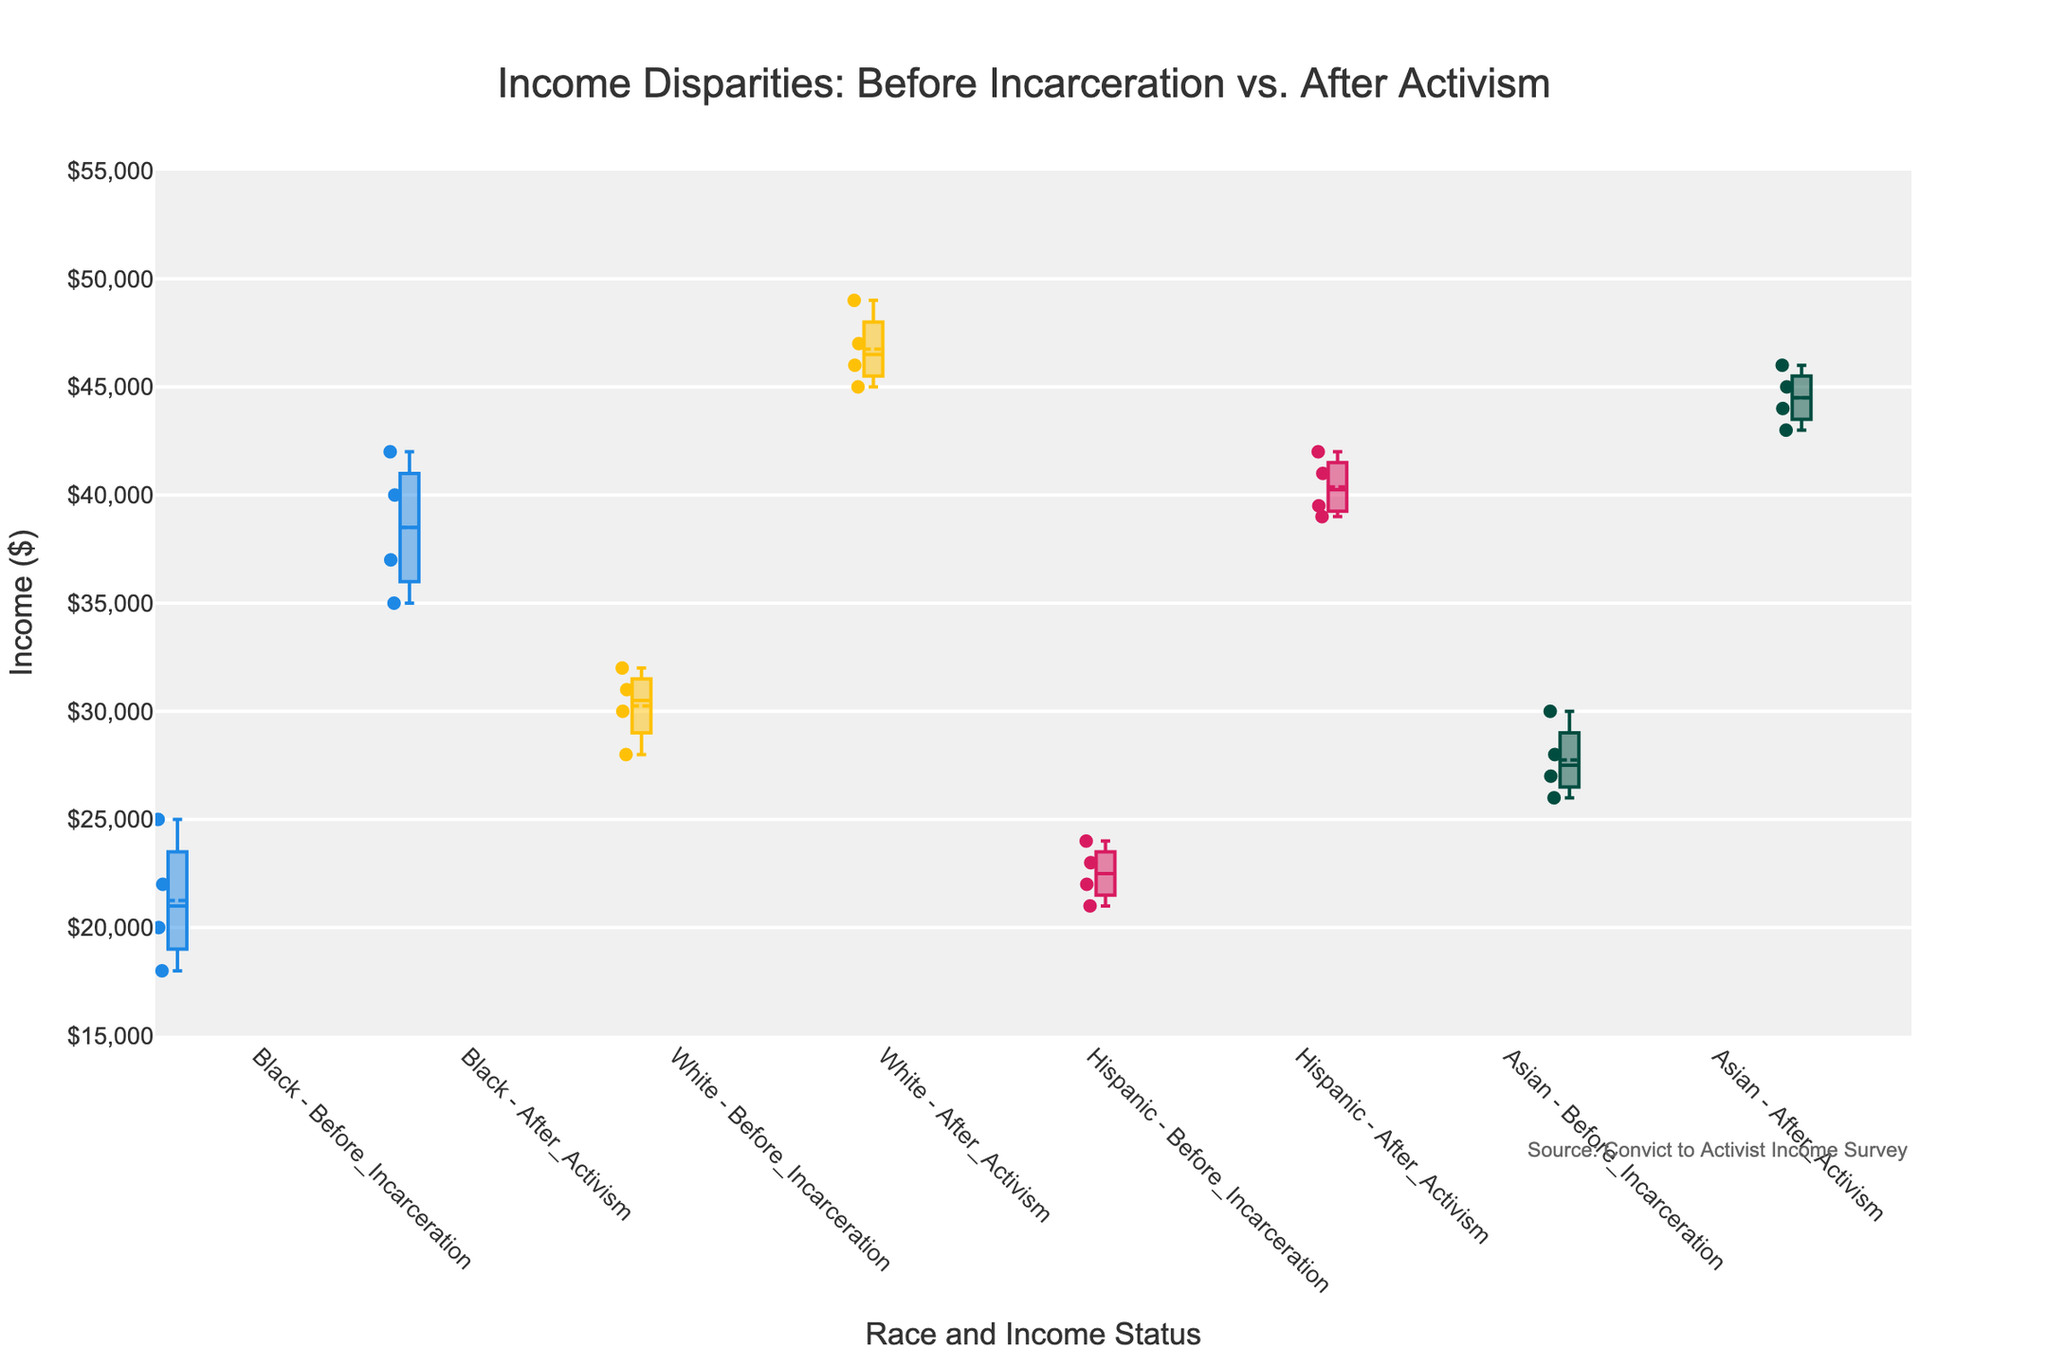What's the title of the figure? The title is typically displayed at the top of the plot and provides an overall description. In this case, it's "Income Disparities: Before Incarceration vs. After Activism."
Answer: Income Disparities: Before Incarceration vs. After Activism What are the x-axis and y-axis titles? The x-axis title describes what categories are displayed along the horizontal axis, while the y-axis title indicates what the vertical axis represents. Here, the x-axis title is "Race and Income Status," and the y-axis title is "Income ($)."
Answer: Race and Income Status, Income ($) Which race group shows the highest increase in median income after activism? By observing the box plot, find the race group where the difference between the median income before incarceration and after becoming an activist is the largest. The "White" group shows the highest increase in median income.
Answer: White How does the median income of Black individuals change after they become activists? View the median line of the box plot for the Black group before incarceration and after activism. It goes from around $19,000 to approximately $38,500.
Answer: Increases by about $19,500 What is the approximate median income of Hispanic individuals after they become activists? The median income is represented by the line within the box of the box plot. For Hispanic individuals after activism, it is around $40,000.
Answer: $40,000 Were there any groups whose income decreased after becoming activists? Inspect the box plots for all race groups. All races show an increase in median income after activism, so no group experienced a decrease.
Answer: No Which group has the least variability in income after becoming activists? Variability in a box plot is shown by the interquartile range (the height of the box). The group with the smallest box is the Asian group after activism.
Answer: Asian Which race had the highest income before incarceration? Compare the median lines for each race before incarceration. The "White" group shows the highest median income.
Answer: White 